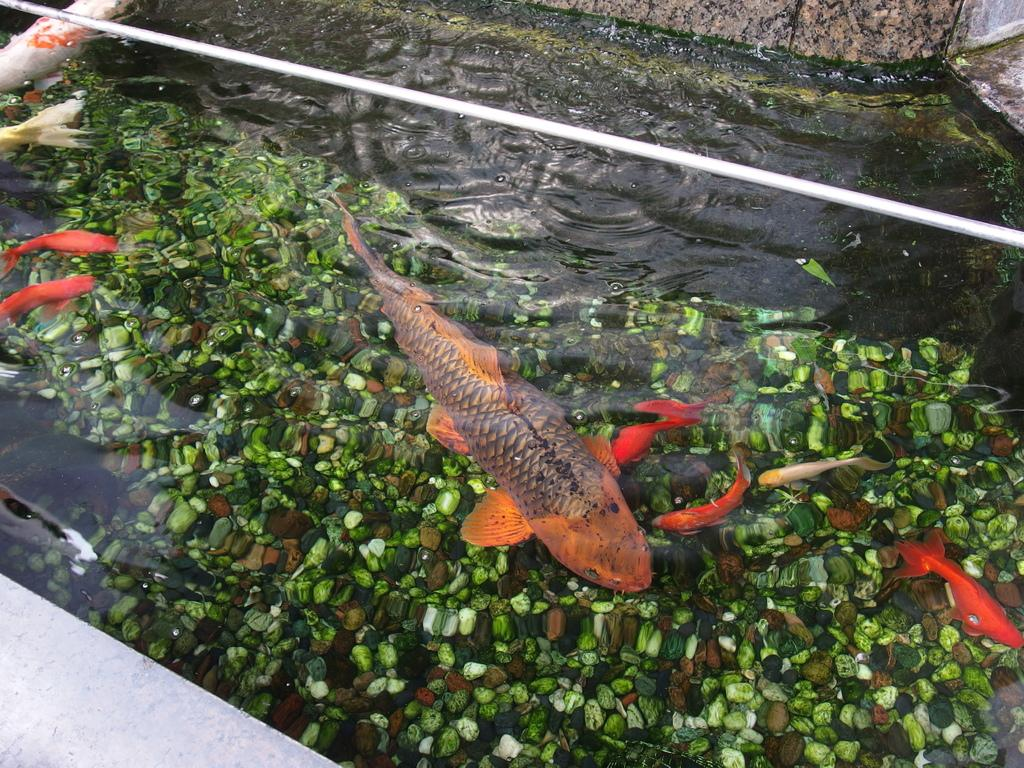What types of animals can be seen in the water in the image? There are different colored fishes in the water in the image. What can be found at the bottom of the aquarium? There are small stones at the bottom of the aquarium. What is located at the top of the aquarium? There is a pipe at the top of the aquarium. What type of plant can be seen growing in the water in the image? There are no plants visible in the image; it only features fishes, small stones, and a pipe in the aquarium. 